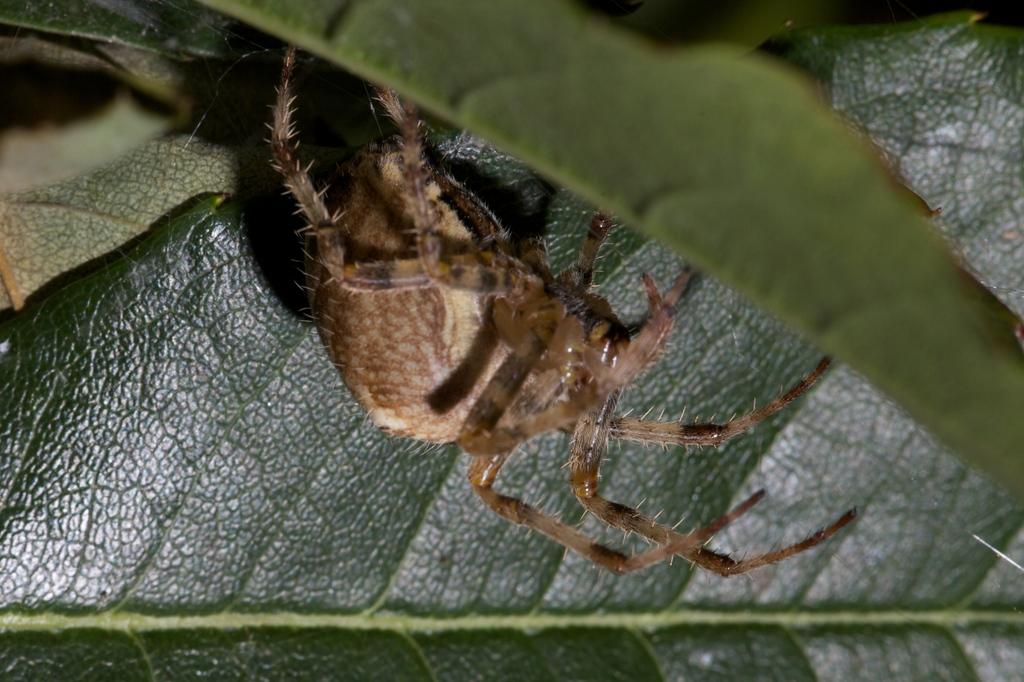What type of creature is present in the image? There is an insect in the image. Can you describe the color pattern of the insect? The insect is black, brown, and cream in color. Where is the insect located in the image? The insect is on a leaf. What is the color of the leaf? The leaf is green in color. What type of lace is being used to decorate the notebook in the image? There is no notebook or lace present in the image; it features an insect on a leaf. 